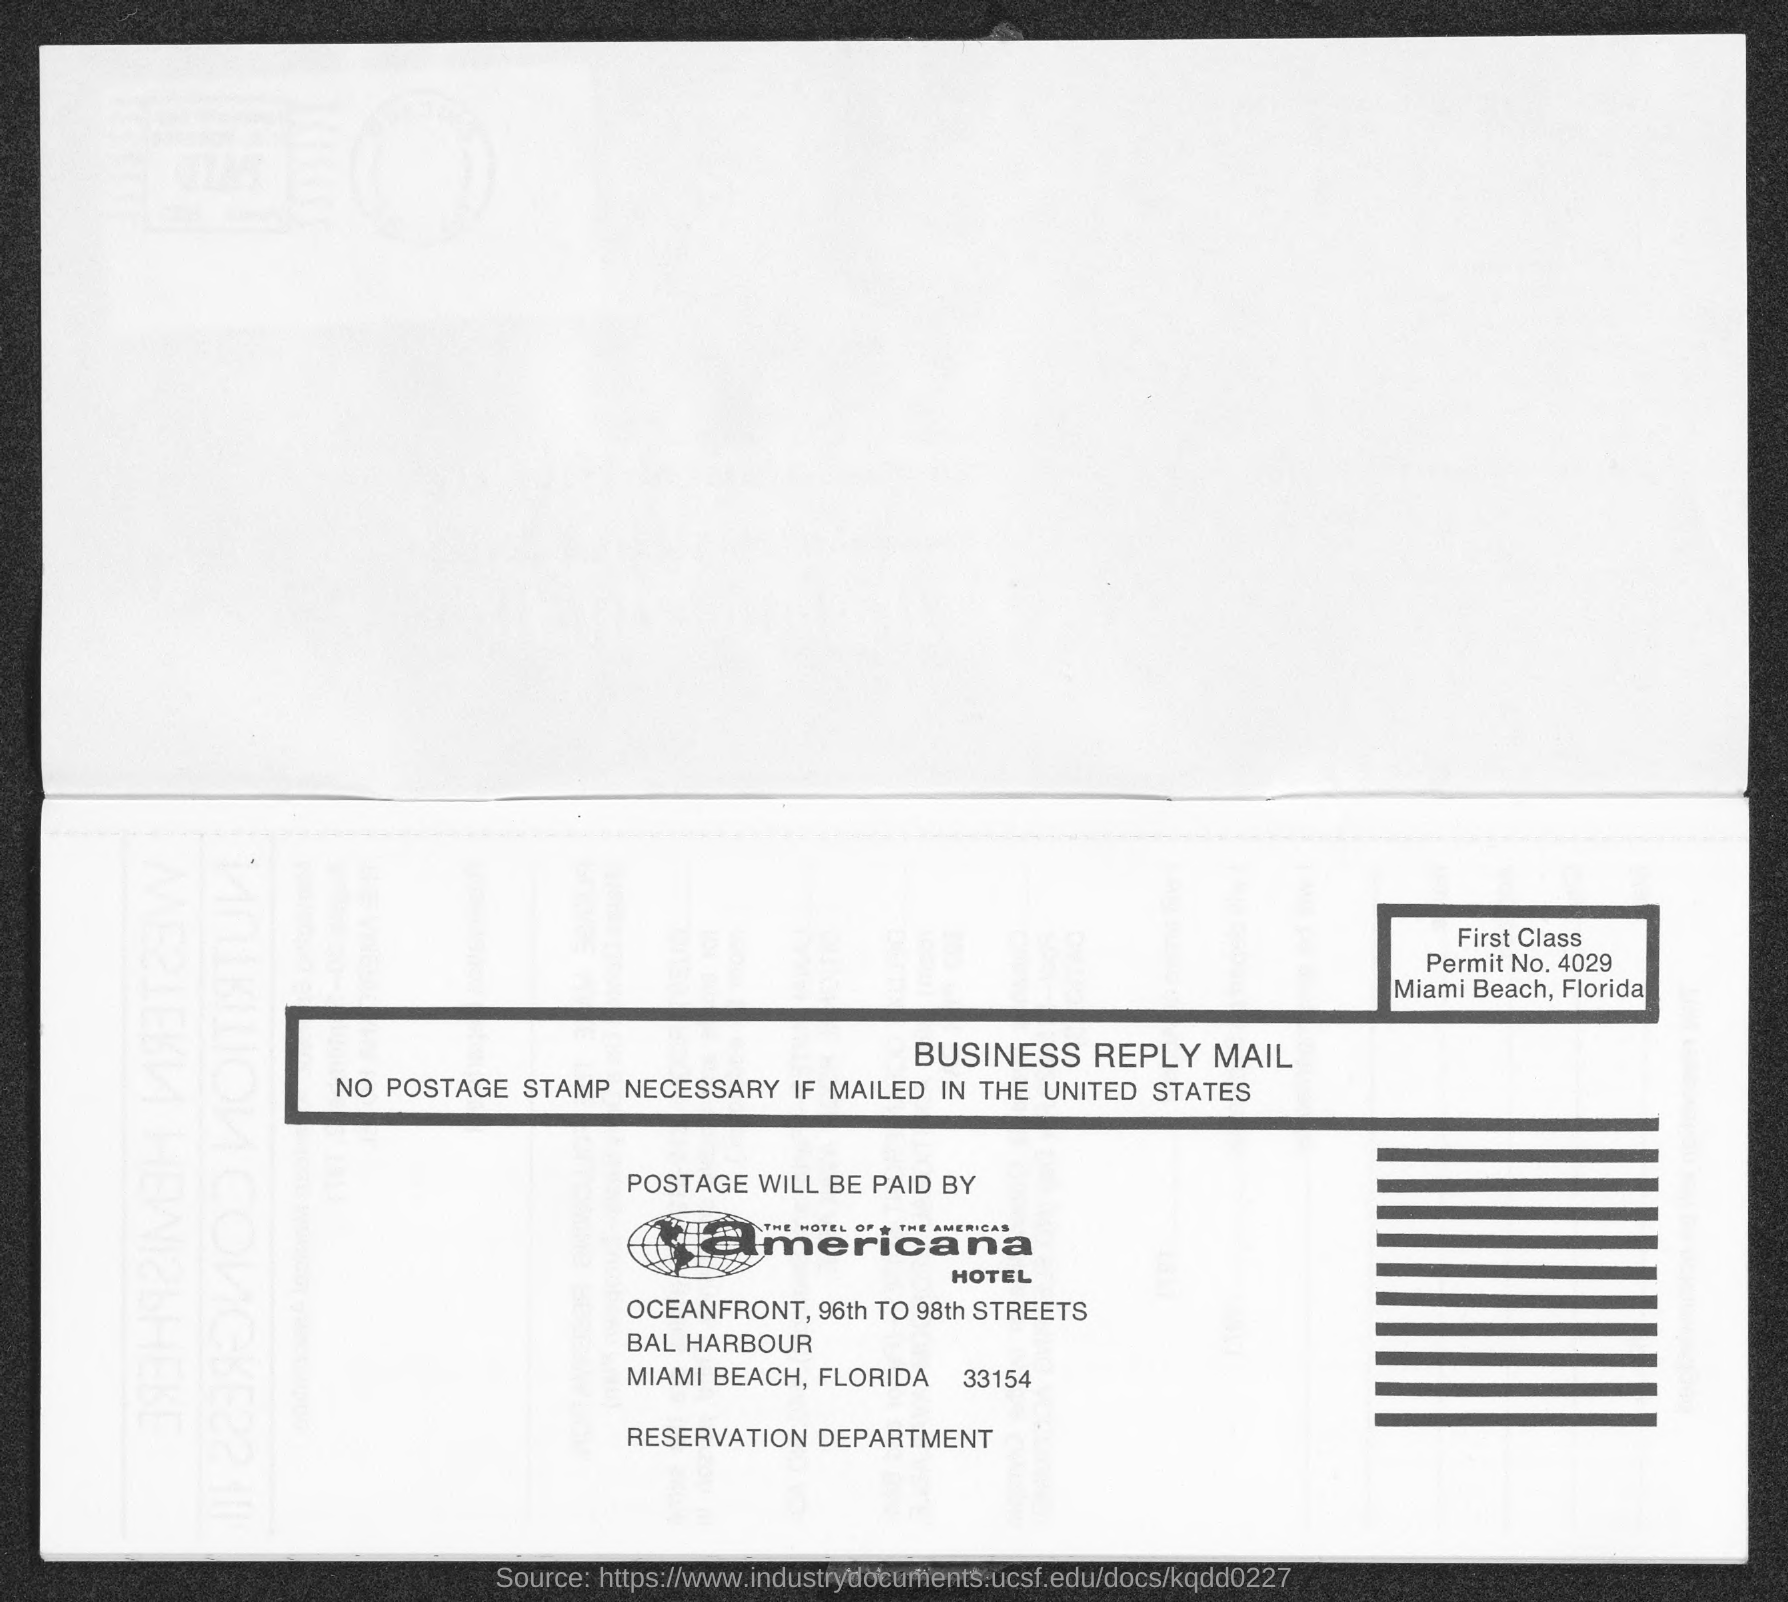In which state is americana hotel located?
Ensure brevity in your answer.  FLORIDA. What is the permit no.?
Give a very brief answer. 4029. 